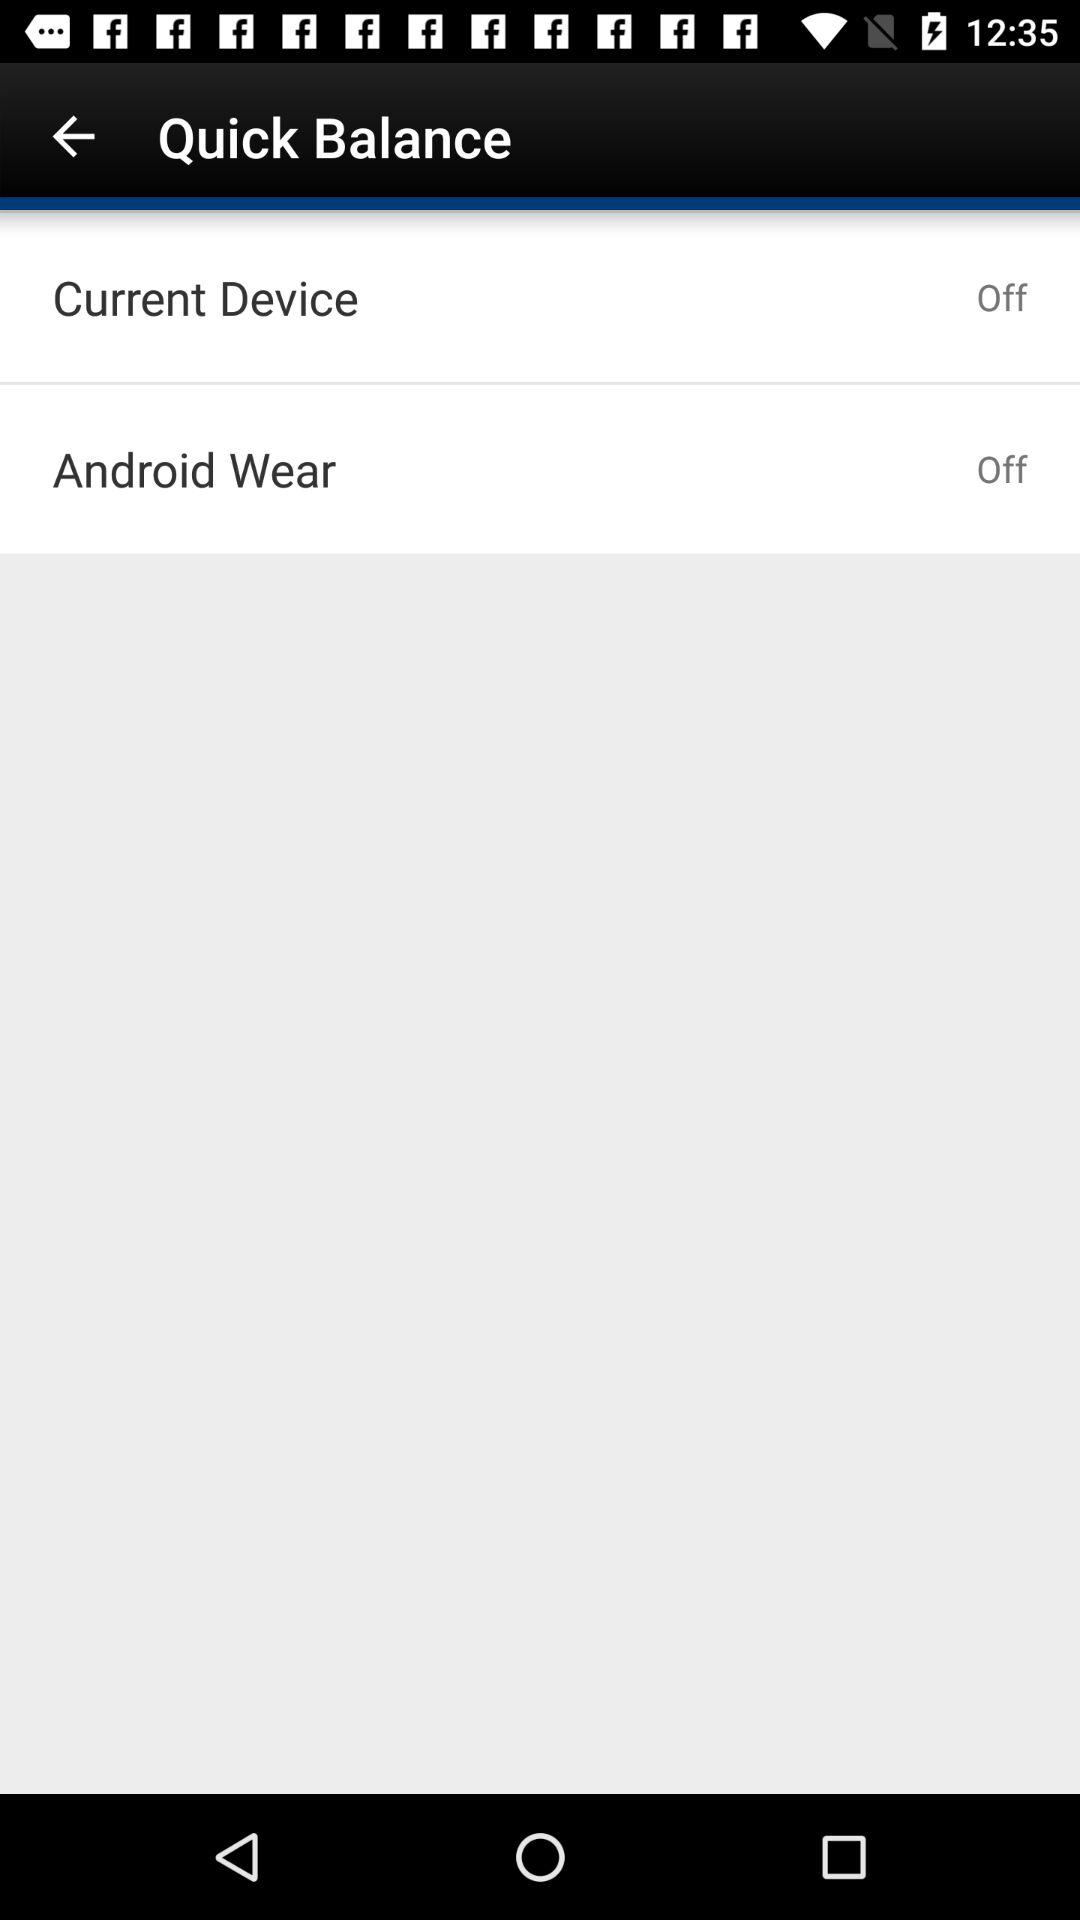What is the status of "Current Device"? The status is "Off". 